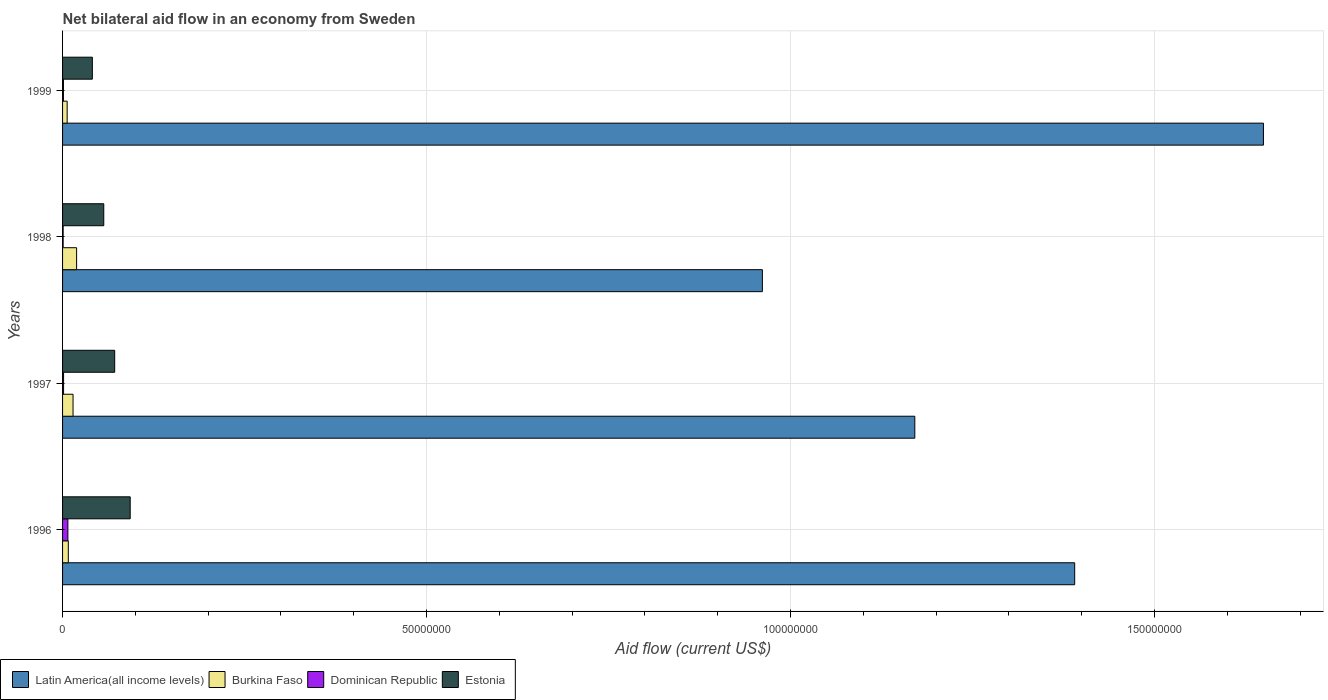How many different coloured bars are there?
Your answer should be compact. 4. Are the number of bars per tick equal to the number of legend labels?
Make the answer very short. Yes. Are the number of bars on each tick of the Y-axis equal?
Keep it short and to the point. Yes. How many bars are there on the 4th tick from the top?
Ensure brevity in your answer.  4. What is the net bilateral aid flow in Dominican Republic in 1997?
Keep it short and to the point. 1.40e+05. Across all years, what is the maximum net bilateral aid flow in Dominican Republic?
Offer a terse response. 7.30e+05. Across all years, what is the minimum net bilateral aid flow in Latin America(all income levels)?
Ensure brevity in your answer.  9.61e+07. In which year was the net bilateral aid flow in Burkina Faso maximum?
Offer a very short reply. 1998. In which year was the net bilateral aid flow in Dominican Republic minimum?
Give a very brief answer. 1998. What is the total net bilateral aid flow in Latin America(all income levels) in the graph?
Your response must be concise. 5.17e+08. What is the difference between the net bilateral aid flow in Latin America(all income levels) in 1998 and that in 1999?
Make the answer very short. -6.88e+07. What is the difference between the net bilateral aid flow in Burkina Faso in 1997 and the net bilateral aid flow in Latin America(all income levels) in 1999?
Ensure brevity in your answer.  -1.64e+08. What is the average net bilateral aid flow in Burkina Faso per year?
Ensure brevity in your answer.  1.20e+06. In the year 1996, what is the difference between the net bilateral aid flow in Estonia and net bilateral aid flow in Latin America(all income levels)?
Your answer should be very brief. -1.30e+08. What is the ratio of the net bilateral aid flow in Burkina Faso in 1996 to that in 1999?
Ensure brevity in your answer.  1.25. Is the net bilateral aid flow in Latin America(all income levels) in 1997 less than that in 1998?
Provide a short and direct response. No. Is the difference between the net bilateral aid flow in Estonia in 1996 and 1998 greater than the difference between the net bilateral aid flow in Latin America(all income levels) in 1996 and 1998?
Offer a very short reply. No. What is the difference between the highest and the second highest net bilateral aid flow in Latin America(all income levels)?
Your answer should be compact. 2.59e+07. What is the difference between the highest and the lowest net bilateral aid flow in Burkina Faso?
Give a very brief answer. 1.30e+06. In how many years, is the net bilateral aid flow in Burkina Faso greater than the average net bilateral aid flow in Burkina Faso taken over all years?
Give a very brief answer. 2. Is the sum of the net bilateral aid flow in Estonia in 1997 and 1999 greater than the maximum net bilateral aid flow in Latin America(all income levels) across all years?
Your answer should be compact. No. What does the 3rd bar from the top in 1999 represents?
Offer a terse response. Burkina Faso. What does the 4th bar from the bottom in 1996 represents?
Provide a short and direct response. Estonia. Is it the case that in every year, the sum of the net bilateral aid flow in Dominican Republic and net bilateral aid flow in Estonia is greater than the net bilateral aid flow in Latin America(all income levels)?
Give a very brief answer. No. How many bars are there?
Provide a short and direct response. 16. Are all the bars in the graph horizontal?
Give a very brief answer. Yes. How many years are there in the graph?
Offer a terse response. 4. What is the difference between two consecutive major ticks on the X-axis?
Ensure brevity in your answer.  5.00e+07. Are the values on the major ticks of X-axis written in scientific E-notation?
Offer a very short reply. No. How are the legend labels stacked?
Your answer should be compact. Horizontal. What is the title of the graph?
Offer a very short reply. Net bilateral aid flow in an economy from Sweden. What is the Aid flow (current US$) of Latin America(all income levels) in 1996?
Keep it short and to the point. 1.39e+08. What is the Aid flow (current US$) in Burkina Faso in 1996?
Make the answer very short. 7.90e+05. What is the Aid flow (current US$) in Dominican Republic in 1996?
Your answer should be compact. 7.30e+05. What is the Aid flow (current US$) in Estonia in 1996?
Your answer should be very brief. 9.29e+06. What is the Aid flow (current US$) in Latin America(all income levels) in 1997?
Your answer should be very brief. 1.17e+08. What is the Aid flow (current US$) in Burkina Faso in 1997?
Offer a terse response. 1.44e+06. What is the Aid flow (current US$) in Dominican Republic in 1997?
Your answer should be very brief. 1.40e+05. What is the Aid flow (current US$) of Estonia in 1997?
Keep it short and to the point. 7.16e+06. What is the Aid flow (current US$) of Latin America(all income levels) in 1998?
Provide a short and direct response. 9.61e+07. What is the Aid flow (current US$) in Burkina Faso in 1998?
Make the answer very short. 1.93e+06. What is the Aid flow (current US$) of Estonia in 1998?
Offer a very short reply. 5.66e+06. What is the Aid flow (current US$) in Latin America(all income levels) in 1999?
Keep it short and to the point. 1.65e+08. What is the Aid flow (current US$) in Burkina Faso in 1999?
Keep it short and to the point. 6.30e+05. What is the Aid flow (current US$) in Estonia in 1999?
Your response must be concise. 4.09e+06. Across all years, what is the maximum Aid flow (current US$) of Latin America(all income levels)?
Your answer should be compact. 1.65e+08. Across all years, what is the maximum Aid flow (current US$) of Burkina Faso?
Keep it short and to the point. 1.93e+06. Across all years, what is the maximum Aid flow (current US$) of Dominican Republic?
Your answer should be very brief. 7.30e+05. Across all years, what is the maximum Aid flow (current US$) in Estonia?
Make the answer very short. 9.29e+06. Across all years, what is the minimum Aid flow (current US$) in Latin America(all income levels)?
Provide a short and direct response. 9.61e+07. Across all years, what is the minimum Aid flow (current US$) of Burkina Faso?
Ensure brevity in your answer.  6.30e+05. Across all years, what is the minimum Aid flow (current US$) of Estonia?
Provide a short and direct response. 4.09e+06. What is the total Aid flow (current US$) in Latin America(all income levels) in the graph?
Provide a short and direct response. 5.17e+08. What is the total Aid flow (current US$) in Burkina Faso in the graph?
Keep it short and to the point. 4.79e+06. What is the total Aid flow (current US$) in Dominican Republic in the graph?
Provide a short and direct response. 1.07e+06. What is the total Aid flow (current US$) of Estonia in the graph?
Your answer should be compact. 2.62e+07. What is the difference between the Aid flow (current US$) of Latin America(all income levels) in 1996 and that in 1997?
Give a very brief answer. 2.20e+07. What is the difference between the Aid flow (current US$) of Burkina Faso in 1996 and that in 1997?
Offer a very short reply. -6.50e+05. What is the difference between the Aid flow (current US$) of Dominican Republic in 1996 and that in 1997?
Ensure brevity in your answer.  5.90e+05. What is the difference between the Aid flow (current US$) of Estonia in 1996 and that in 1997?
Your answer should be compact. 2.13e+06. What is the difference between the Aid flow (current US$) of Latin America(all income levels) in 1996 and that in 1998?
Provide a succinct answer. 4.29e+07. What is the difference between the Aid flow (current US$) of Burkina Faso in 1996 and that in 1998?
Give a very brief answer. -1.14e+06. What is the difference between the Aid flow (current US$) in Dominican Republic in 1996 and that in 1998?
Provide a succinct answer. 6.50e+05. What is the difference between the Aid flow (current US$) in Estonia in 1996 and that in 1998?
Make the answer very short. 3.63e+06. What is the difference between the Aid flow (current US$) in Latin America(all income levels) in 1996 and that in 1999?
Give a very brief answer. -2.59e+07. What is the difference between the Aid flow (current US$) in Estonia in 1996 and that in 1999?
Your response must be concise. 5.20e+06. What is the difference between the Aid flow (current US$) of Latin America(all income levels) in 1997 and that in 1998?
Your answer should be very brief. 2.09e+07. What is the difference between the Aid flow (current US$) in Burkina Faso in 1997 and that in 1998?
Your response must be concise. -4.90e+05. What is the difference between the Aid flow (current US$) of Dominican Republic in 1997 and that in 1998?
Provide a short and direct response. 6.00e+04. What is the difference between the Aid flow (current US$) in Estonia in 1997 and that in 1998?
Your response must be concise. 1.50e+06. What is the difference between the Aid flow (current US$) of Latin America(all income levels) in 1997 and that in 1999?
Make the answer very short. -4.79e+07. What is the difference between the Aid flow (current US$) of Burkina Faso in 1997 and that in 1999?
Your response must be concise. 8.10e+05. What is the difference between the Aid flow (current US$) in Dominican Republic in 1997 and that in 1999?
Provide a succinct answer. 2.00e+04. What is the difference between the Aid flow (current US$) in Estonia in 1997 and that in 1999?
Provide a short and direct response. 3.07e+06. What is the difference between the Aid flow (current US$) of Latin America(all income levels) in 1998 and that in 1999?
Provide a short and direct response. -6.88e+07. What is the difference between the Aid flow (current US$) in Burkina Faso in 1998 and that in 1999?
Offer a terse response. 1.30e+06. What is the difference between the Aid flow (current US$) in Estonia in 1998 and that in 1999?
Your answer should be compact. 1.57e+06. What is the difference between the Aid flow (current US$) of Latin America(all income levels) in 1996 and the Aid flow (current US$) of Burkina Faso in 1997?
Ensure brevity in your answer.  1.38e+08. What is the difference between the Aid flow (current US$) of Latin America(all income levels) in 1996 and the Aid flow (current US$) of Dominican Republic in 1997?
Keep it short and to the point. 1.39e+08. What is the difference between the Aid flow (current US$) in Latin America(all income levels) in 1996 and the Aid flow (current US$) in Estonia in 1997?
Keep it short and to the point. 1.32e+08. What is the difference between the Aid flow (current US$) of Burkina Faso in 1996 and the Aid flow (current US$) of Dominican Republic in 1997?
Give a very brief answer. 6.50e+05. What is the difference between the Aid flow (current US$) in Burkina Faso in 1996 and the Aid flow (current US$) in Estonia in 1997?
Your answer should be compact. -6.37e+06. What is the difference between the Aid flow (current US$) of Dominican Republic in 1996 and the Aid flow (current US$) of Estonia in 1997?
Your answer should be very brief. -6.43e+06. What is the difference between the Aid flow (current US$) of Latin America(all income levels) in 1996 and the Aid flow (current US$) of Burkina Faso in 1998?
Keep it short and to the point. 1.37e+08. What is the difference between the Aid flow (current US$) of Latin America(all income levels) in 1996 and the Aid flow (current US$) of Dominican Republic in 1998?
Ensure brevity in your answer.  1.39e+08. What is the difference between the Aid flow (current US$) of Latin America(all income levels) in 1996 and the Aid flow (current US$) of Estonia in 1998?
Make the answer very short. 1.33e+08. What is the difference between the Aid flow (current US$) of Burkina Faso in 1996 and the Aid flow (current US$) of Dominican Republic in 1998?
Offer a terse response. 7.10e+05. What is the difference between the Aid flow (current US$) in Burkina Faso in 1996 and the Aid flow (current US$) in Estonia in 1998?
Your answer should be very brief. -4.87e+06. What is the difference between the Aid flow (current US$) of Dominican Republic in 1996 and the Aid flow (current US$) of Estonia in 1998?
Your answer should be compact. -4.93e+06. What is the difference between the Aid flow (current US$) of Latin America(all income levels) in 1996 and the Aid flow (current US$) of Burkina Faso in 1999?
Keep it short and to the point. 1.38e+08. What is the difference between the Aid flow (current US$) in Latin America(all income levels) in 1996 and the Aid flow (current US$) in Dominican Republic in 1999?
Offer a very short reply. 1.39e+08. What is the difference between the Aid flow (current US$) in Latin America(all income levels) in 1996 and the Aid flow (current US$) in Estonia in 1999?
Offer a very short reply. 1.35e+08. What is the difference between the Aid flow (current US$) of Burkina Faso in 1996 and the Aid flow (current US$) of Dominican Republic in 1999?
Ensure brevity in your answer.  6.70e+05. What is the difference between the Aid flow (current US$) in Burkina Faso in 1996 and the Aid flow (current US$) in Estonia in 1999?
Provide a short and direct response. -3.30e+06. What is the difference between the Aid flow (current US$) in Dominican Republic in 1996 and the Aid flow (current US$) in Estonia in 1999?
Make the answer very short. -3.36e+06. What is the difference between the Aid flow (current US$) in Latin America(all income levels) in 1997 and the Aid flow (current US$) in Burkina Faso in 1998?
Ensure brevity in your answer.  1.15e+08. What is the difference between the Aid flow (current US$) in Latin America(all income levels) in 1997 and the Aid flow (current US$) in Dominican Republic in 1998?
Give a very brief answer. 1.17e+08. What is the difference between the Aid flow (current US$) in Latin America(all income levels) in 1997 and the Aid flow (current US$) in Estonia in 1998?
Offer a terse response. 1.11e+08. What is the difference between the Aid flow (current US$) in Burkina Faso in 1997 and the Aid flow (current US$) in Dominican Republic in 1998?
Provide a short and direct response. 1.36e+06. What is the difference between the Aid flow (current US$) in Burkina Faso in 1997 and the Aid flow (current US$) in Estonia in 1998?
Offer a terse response. -4.22e+06. What is the difference between the Aid flow (current US$) in Dominican Republic in 1997 and the Aid flow (current US$) in Estonia in 1998?
Your response must be concise. -5.52e+06. What is the difference between the Aid flow (current US$) in Latin America(all income levels) in 1997 and the Aid flow (current US$) in Burkina Faso in 1999?
Provide a short and direct response. 1.16e+08. What is the difference between the Aid flow (current US$) in Latin America(all income levels) in 1997 and the Aid flow (current US$) in Dominican Republic in 1999?
Offer a very short reply. 1.17e+08. What is the difference between the Aid flow (current US$) of Latin America(all income levels) in 1997 and the Aid flow (current US$) of Estonia in 1999?
Make the answer very short. 1.13e+08. What is the difference between the Aid flow (current US$) of Burkina Faso in 1997 and the Aid flow (current US$) of Dominican Republic in 1999?
Your answer should be compact. 1.32e+06. What is the difference between the Aid flow (current US$) of Burkina Faso in 1997 and the Aid flow (current US$) of Estonia in 1999?
Provide a short and direct response. -2.65e+06. What is the difference between the Aid flow (current US$) in Dominican Republic in 1997 and the Aid flow (current US$) in Estonia in 1999?
Your response must be concise. -3.95e+06. What is the difference between the Aid flow (current US$) of Latin America(all income levels) in 1998 and the Aid flow (current US$) of Burkina Faso in 1999?
Give a very brief answer. 9.55e+07. What is the difference between the Aid flow (current US$) in Latin America(all income levels) in 1998 and the Aid flow (current US$) in Dominican Republic in 1999?
Offer a terse response. 9.60e+07. What is the difference between the Aid flow (current US$) of Latin America(all income levels) in 1998 and the Aid flow (current US$) of Estonia in 1999?
Ensure brevity in your answer.  9.20e+07. What is the difference between the Aid flow (current US$) of Burkina Faso in 1998 and the Aid flow (current US$) of Dominican Republic in 1999?
Provide a short and direct response. 1.81e+06. What is the difference between the Aid flow (current US$) of Burkina Faso in 1998 and the Aid flow (current US$) of Estonia in 1999?
Ensure brevity in your answer.  -2.16e+06. What is the difference between the Aid flow (current US$) in Dominican Republic in 1998 and the Aid flow (current US$) in Estonia in 1999?
Keep it short and to the point. -4.01e+06. What is the average Aid flow (current US$) of Latin America(all income levels) per year?
Keep it short and to the point. 1.29e+08. What is the average Aid flow (current US$) in Burkina Faso per year?
Provide a short and direct response. 1.20e+06. What is the average Aid flow (current US$) in Dominican Republic per year?
Your answer should be very brief. 2.68e+05. What is the average Aid flow (current US$) of Estonia per year?
Ensure brevity in your answer.  6.55e+06. In the year 1996, what is the difference between the Aid flow (current US$) of Latin America(all income levels) and Aid flow (current US$) of Burkina Faso?
Give a very brief answer. 1.38e+08. In the year 1996, what is the difference between the Aid flow (current US$) of Latin America(all income levels) and Aid flow (current US$) of Dominican Republic?
Your answer should be compact. 1.38e+08. In the year 1996, what is the difference between the Aid flow (current US$) in Latin America(all income levels) and Aid flow (current US$) in Estonia?
Provide a succinct answer. 1.30e+08. In the year 1996, what is the difference between the Aid flow (current US$) of Burkina Faso and Aid flow (current US$) of Estonia?
Provide a succinct answer. -8.50e+06. In the year 1996, what is the difference between the Aid flow (current US$) of Dominican Republic and Aid flow (current US$) of Estonia?
Your answer should be compact. -8.56e+06. In the year 1997, what is the difference between the Aid flow (current US$) of Latin America(all income levels) and Aid flow (current US$) of Burkina Faso?
Your answer should be very brief. 1.16e+08. In the year 1997, what is the difference between the Aid flow (current US$) of Latin America(all income levels) and Aid flow (current US$) of Dominican Republic?
Keep it short and to the point. 1.17e+08. In the year 1997, what is the difference between the Aid flow (current US$) in Latin America(all income levels) and Aid flow (current US$) in Estonia?
Make the answer very short. 1.10e+08. In the year 1997, what is the difference between the Aid flow (current US$) in Burkina Faso and Aid flow (current US$) in Dominican Republic?
Your answer should be very brief. 1.30e+06. In the year 1997, what is the difference between the Aid flow (current US$) of Burkina Faso and Aid flow (current US$) of Estonia?
Offer a very short reply. -5.72e+06. In the year 1997, what is the difference between the Aid flow (current US$) in Dominican Republic and Aid flow (current US$) in Estonia?
Your answer should be very brief. -7.02e+06. In the year 1998, what is the difference between the Aid flow (current US$) in Latin America(all income levels) and Aid flow (current US$) in Burkina Faso?
Keep it short and to the point. 9.42e+07. In the year 1998, what is the difference between the Aid flow (current US$) in Latin America(all income levels) and Aid flow (current US$) in Dominican Republic?
Make the answer very short. 9.60e+07. In the year 1998, what is the difference between the Aid flow (current US$) in Latin America(all income levels) and Aid flow (current US$) in Estonia?
Offer a terse response. 9.05e+07. In the year 1998, what is the difference between the Aid flow (current US$) of Burkina Faso and Aid flow (current US$) of Dominican Republic?
Ensure brevity in your answer.  1.85e+06. In the year 1998, what is the difference between the Aid flow (current US$) in Burkina Faso and Aid flow (current US$) in Estonia?
Provide a short and direct response. -3.73e+06. In the year 1998, what is the difference between the Aid flow (current US$) in Dominican Republic and Aid flow (current US$) in Estonia?
Ensure brevity in your answer.  -5.58e+06. In the year 1999, what is the difference between the Aid flow (current US$) of Latin America(all income levels) and Aid flow (current US$) of Burkina Faso?
Make the answer very short. 1.64e+08. In the year 1999, what is the difference between the Aid flow (current US$) in Latin America(all income levels) and Aid flow (current US$) in Dominican Republic?
Offer a very short reply. 1.65e+08. In the year 1999, what is the difference between the Aid flow (current US$) in Latin America(all income levels) and Aid flow (current US$) in Estonia?
Ensure brevity in your answer.  1.61e+08. In the year 1999, what is the difference between the Aid flow (current US$) of Burkina Faso and Aid flow (current US$) of Dominican Republic?
Give a very brief answer. 5.10e+05. In the year 1999, what is the difference between the Aid flow (current US$) in Burkina Faso and Aid flow (current US$) in Estonia?
Offer a very short reply. -3.46e+06. In the year 1999, what is the difference between the Aid flow (current US$) of Dominican Republic and Aid flow (current US$) of Estonia?
Your answer should be compact. -3.97e+06. What is the ratio of the Aid flow (current US$) in Latin America(all income levels) in 1996 to that in 1997?
Provide a short and direct response. 1.19. What is the ratio of the Aid flow (current US$) in Burkina Faso in 1996 to that in 1997?
Your response must be concise. 0.55. What is the ratio of the Aid flow (current US$) in Dominican Republic in 1996 to that in 1997?
Make the answer very short. 5.21. What is the ratio of the Aid flow (current US$) in Estonia in 1996 to that in 1997?
Make the answer very short. 1.3. What is the ratio of the Aid flow (current US$) in Latin America(all income levels) in 1996 to that in 1998?
Offer a terse response. 1.45. What is the ratio of the Aid flow (current US$) in Burkina Faso in 1996 to that in 1998?
Make the answer very short. 0.41. What is the ratio of the Aid flow (current US$) of Dominican Republic in 1996 to that in 1998?
Make the answer very short. 9.12. What is the ratio of the Aid flow (current US$) in Estonia in 1996 to that in 1998?
Your response must be concise. 1.64. What is the ratio of the Aid flow (current US$) of Latin America(all income levels) in 1996 to that in 1999?
Ensure brevity in your answer.  0.84. What is the ratio of the Aid flow (current US$) of Burkina Faso in 1996 to that in 1999?
Keep it short and to the point. 1.25. What is the ratio of the Aid flow (current US$) of Dominican Republic in 1996 to that in 1999?
Your response must be concise. 6.08. What is the ratio of the Aid flow (current US$) in Estonia in 1996 to that in 1999?
Offer a very short reply. 2.27. What is the ratio of the Aid flow (current US$) of Latin America(all income levels) in 1997 to that in 1998?
Provide a short and direct response. 1.22. What is the ratio of the Aid flow (current US$) in Burkina Faso in 1997 to that in 1998?
Your response must be concise. 0.75. What is the ratio of the Aid flow (current US$) in Estonia in 1997 to that in 1998?
Your response must be concise. 1.26. What is the ratio of the Aid flow (current US$) in Latin America(all income levels) in 1997 to that in 1999?
Provide a succinct answer. 0.71. What is the ratio of the Aid flow (current US$) in Burkina Faso in 1997 to that in 1999?
Your answer should be compact. 2.29. What is the ratio of the Aid flow (current US$) of Dominican Republic in 1997 to that in 1999?
Make the answer very short. 1.17. What is the ratio of the Aid flow (current US$) of Estonia in 1997 to that in 1999?
Your answer should be very brief. 1.75. What is the ratio of the Aid flow (current US$) of Latin America(all income levels) in 1998 to that in 1999?
Offer a terse response. 0.58. What is the ratio of the Aid flow (current US$) of Burkina Faso in 1998 to that in 1999?
Your response must be concise. 3.06. What is the ratio of the Aid flow (current US$) of Estonia in 1998 to that in 1999?
Your answer should be compact. 1.38. What is the difference between the highest and the second highest Aid flow (current US$) of Latin America(all income levels)?
Offer a terse response. 2.59e+07. What is the difference between the highest and the second highest Aid flow (current US$) in Dominican Republic?
Offer a terse response. 5.90e+05. What is the difference between the highest and the second highest Aid flow (current US$) in Estonia?
Ensure brevity in your answer.  2.13e+06. What is the difference between the highest and the lowest Aid flow (current US$) of Latin America(all income levels)?
Offer a terse response. 6.88e+07. What is the difference between the highest and the lowest Aid flow (current US$) of Burkina Faso?
Your response must be concise. 1.30e+06. What is the difference between the highest and the lowest Aid flow (current US$) in Dominican Republic?
Make the answer very short. 6.50e+05. What is the difference between the highest and the lowest Aid flow (current US$) in Estonia?
Offer a very short reply. 5.20e+06. 